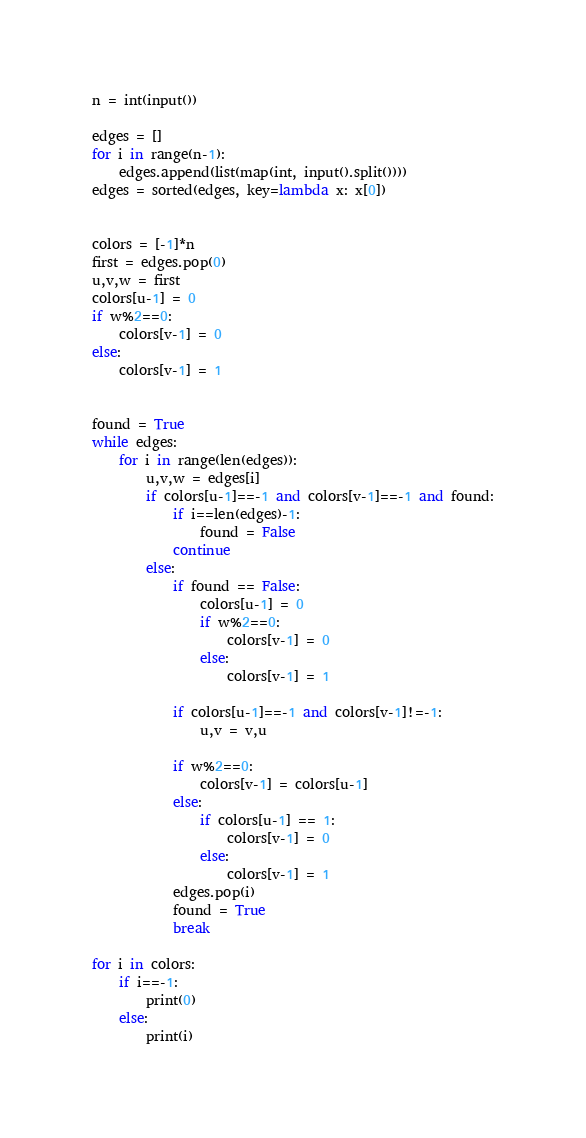<code> <loc_0><loc_0><loc_500><loc_500><_Python_>n = int(input())

edges = []
for i in range(n-1):
	edges.append(list(map(int, input().split())))
edges = sorted(edges, key=lambda x: x[0])


colors = [-1]*n
first = edges.pop(0)
u,v,w = first
colors[u-1] = 0
if w%2==0:
	colors[v-1] = 0
else:
	colors[v-1] = 1


found = True
while edges:
	for i in range(len(edges)):
		u,v,w = edges[i]
		if colors[u-1]==-1 and colors[v-1]==-1 and found:
			if i==len(edges)-1:
				found = False
			continue
		else:
			if found == False:
				colors[u-1] = 0
				if w%2==0:
					colors[v-1] = 0
				else:
					colors[v-1] = 1
					
			if colors[u-1]==-1 and colors[v-1]!=-1:
				u,v = v,u

			if w%2==0:
				colors[v-1] = colors[u-1]
			else:
				if colors[u-1] == 1:
					colors[v-1] = 0
				else:
					colors[v-1] = 1
			edges.pop(i)
			found = True
			break

for i in colors:
	if i==-1:
		print(0)
	else:
		print(i)</code> 